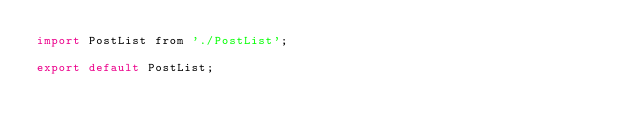<code> <loc_0><loc_0><loc_500><loc_500><_JavaScript_>import PostList from './PostList';

export default PostList;
</code> 